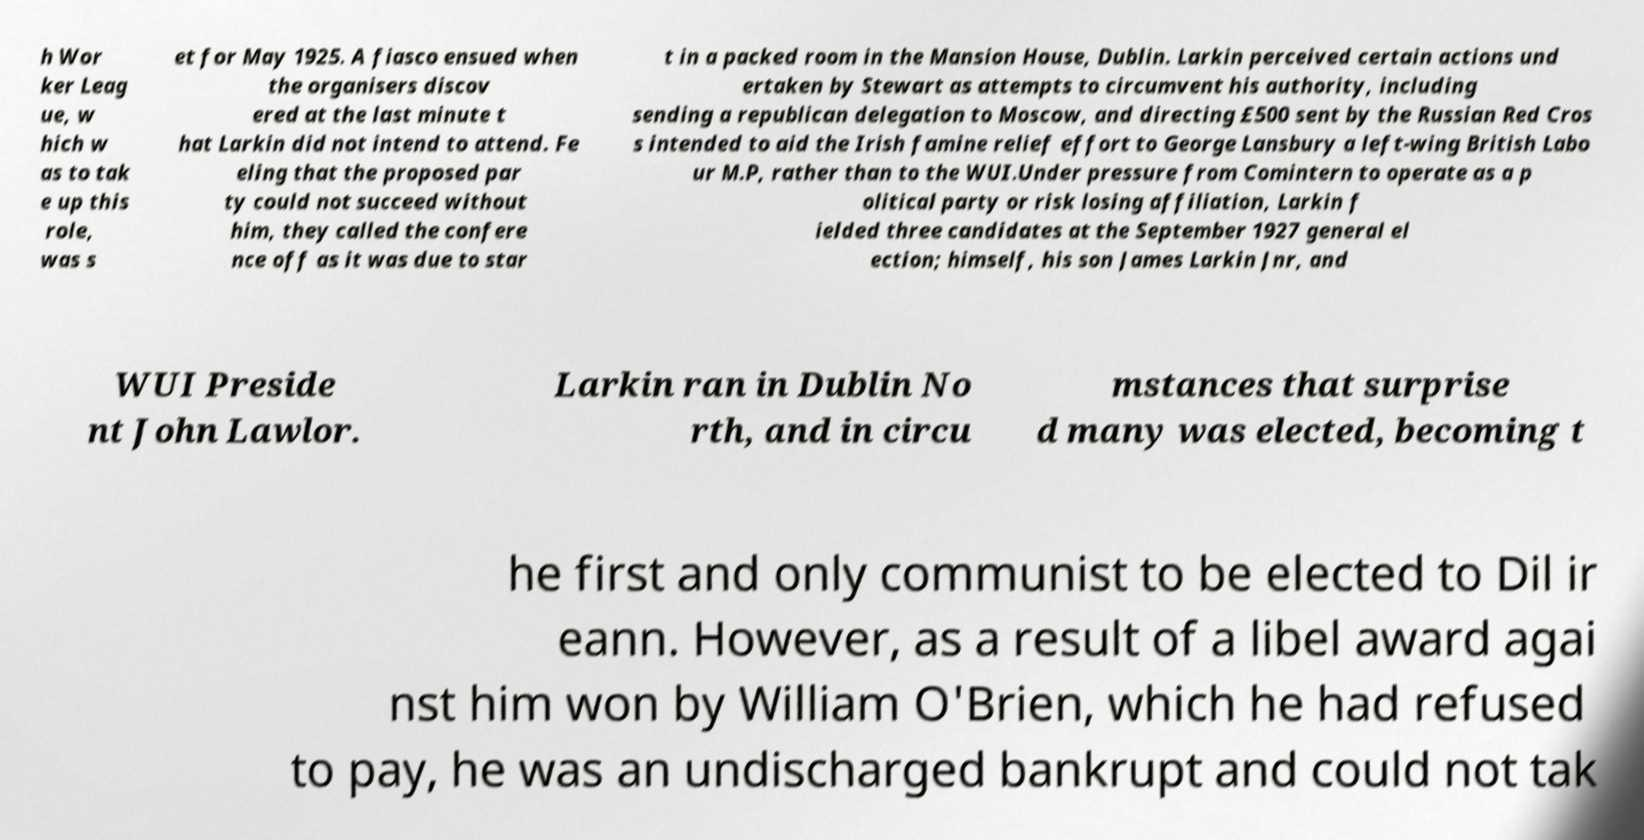For documentation purposes, I need the text within this image transcribed. Could you provide that? h Wor ker Leag ue, w hich w as to tak e up this role, was s et for May 1925. A fiasco ensued when the organisers discov ered at the last minute t hat Larkin did not intend to attend. Fe eling that the proposed par ty could not succeed without him, they called the confere nce off as it was due to star t in a packed room in the Mansion House, Dublin. Larkin perceived certain actions und ertaken by Stewart as attempts to circumvent his authority, including sending a republican delegation to Moscow, and directing £500 sent by the Russian Red Cros s intended to aid the Irish famine relief effort to George Lansbury a left-wing British Labo ur M.P, rather than to the WUI.Under pressure from Comintern to operate as a p olitical party or risk losing affiliation, Larkin f ielded three candidates at the September 1927 general el ection; himself, his son James Larkin Jnr, and WUI Preside nt John Lawlor. Larkin ran in Dublin No rth, and in circu mstances that surprise d many was elected, becoming t he first and only communist to be elected to Dil ir eann. However, as a result of a libel award agai nst him won by William O'Brien, which he had refused to pay, he was an undischarged bankrupt and could not tak 